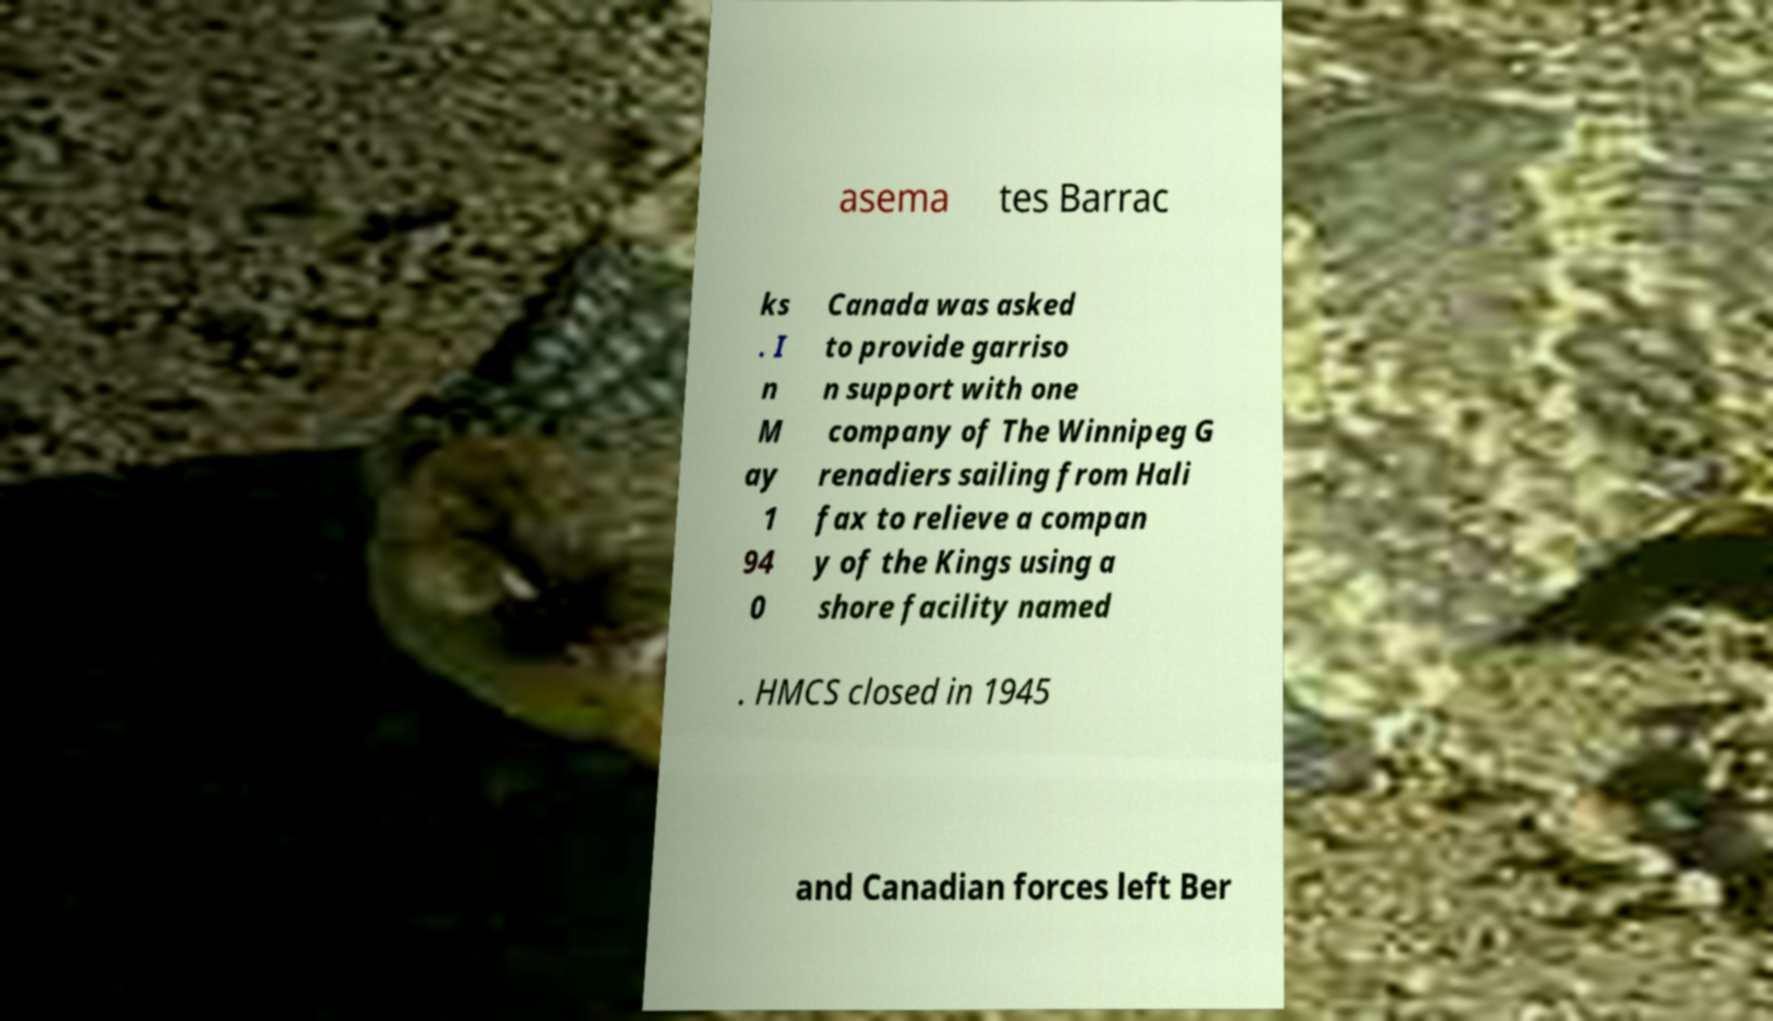Can you read and provide the text displayed in the image?This photo seems to have some interesting text. Can you extract and type it out for me? asema tes Barrac ks . I n M ay 1 94 0 Canada was asked to provide garriso n support with one company of The Winnipeg G renadiers sailing from Hali fax to relieve a compan y of the Kings using a shore facility named . HMCS closed in 1945 and Canadian forces left Ber 